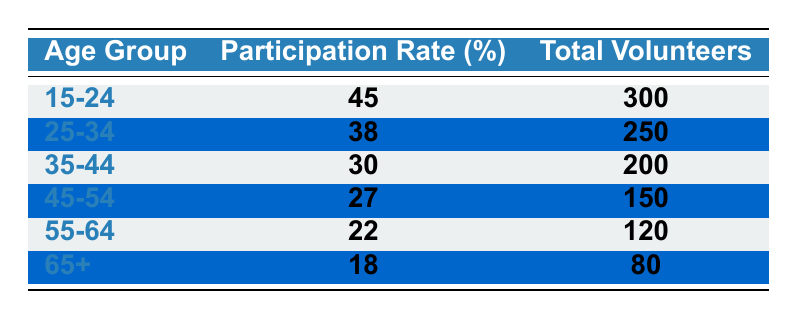What is the participation rate for the age group 25-34? The table shows the participation rate for the age group 25-34 as 38%.
Answer: 38% Which age group has the highest total number of volunteers? Looking at the 'Total Volunteers' column, the age group 15-24 has the highest number with 300 volunteers.
Answer: 15-24 What is the average participation rate across all age groups? To find the average participation rate, we add all the participation rates (45 + 38 + 30 + 27 + 22 + 18 = 180) and divide by the number of age groups (6). The average is 180 / 6 = 30%.
Answer: 30% Is the participation rate for the age group 65+ greater than 20%? The participation rate for the age group 65+ is 18%, which is less than 20%. Therefore, the answer is no.
Answer: No How many total volunteers are in age groups with a participation rate above 30%? The age groups with a participation rate above 30% are 15-24 (300 volunteers), 25-34 (250 volunteers), and 35-44 (200 volunteers). Adding these gives 300 + 250 + 200 = 750 total volunteers.
Answer: 750 What is the difference in participation rate between the age groups 15-24 and 55-64? The participation rate for 15-24 is 45% and for 55-64 is 22%. The difference is 45% - 22% = 23%.
Answer: 23% Which age group shows the least volunteer participation? From the table, the age group 65+ has the lowest participation rate of 18%.
Answer: 65+ What percentage of total volunteers are from the age group 45-54? The total number of volunteers across all age groups is 300 + 250 + 200 + 150 + 120 + 80 = 1100. The age group 45-54 has 150 volunteers. The percentage is (150 / 1100) * 100 = 13.64%.
Answer: 13.64% Is the total number of volunteers in the age group 35-44 more than the total for the age group 55-64? The age group 35-44 has 200 volunteers, while 55-64 has 120 volunteers. Since 200 is greater than 120, the answer is yes.
Answer: Yes What will be the participation rate if the age group 45-54 increased its volunteers to 200? If the age group 45-54 increases its volunteers to 200, the participation will be recalculated as new participation (200/total) * 100. The new total volunteers would be 300 + 250 + 200 + 200 + 120 + 80 = 1150. Thus, the new rate is (200 / 1150) * 100 = 17.39%.
Answer: 17.39% 